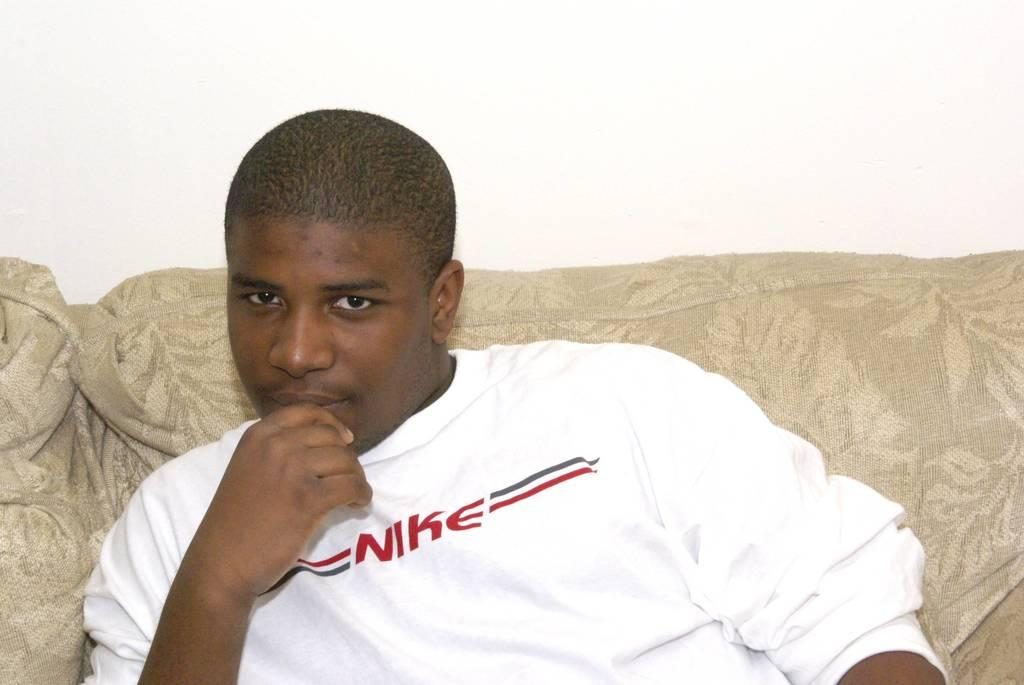Provide a one-sentence caption for the provided image. A man sits on a couch in a white Nike sweater. 